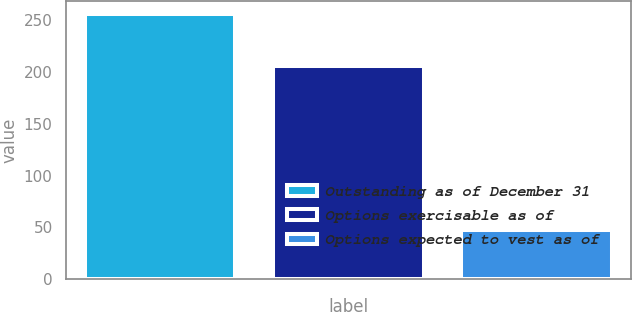Convert chart to OTSL. <chart><loc_0><loc_0><loc_500><loc_500><bar_chart><fcel>Outstanding as of December 31<fcel>Options exercisable as of<fcel>Options expected to vest as of<nl><fcel>255.3<fcel>205.8<fcel>48<nl></chart> 